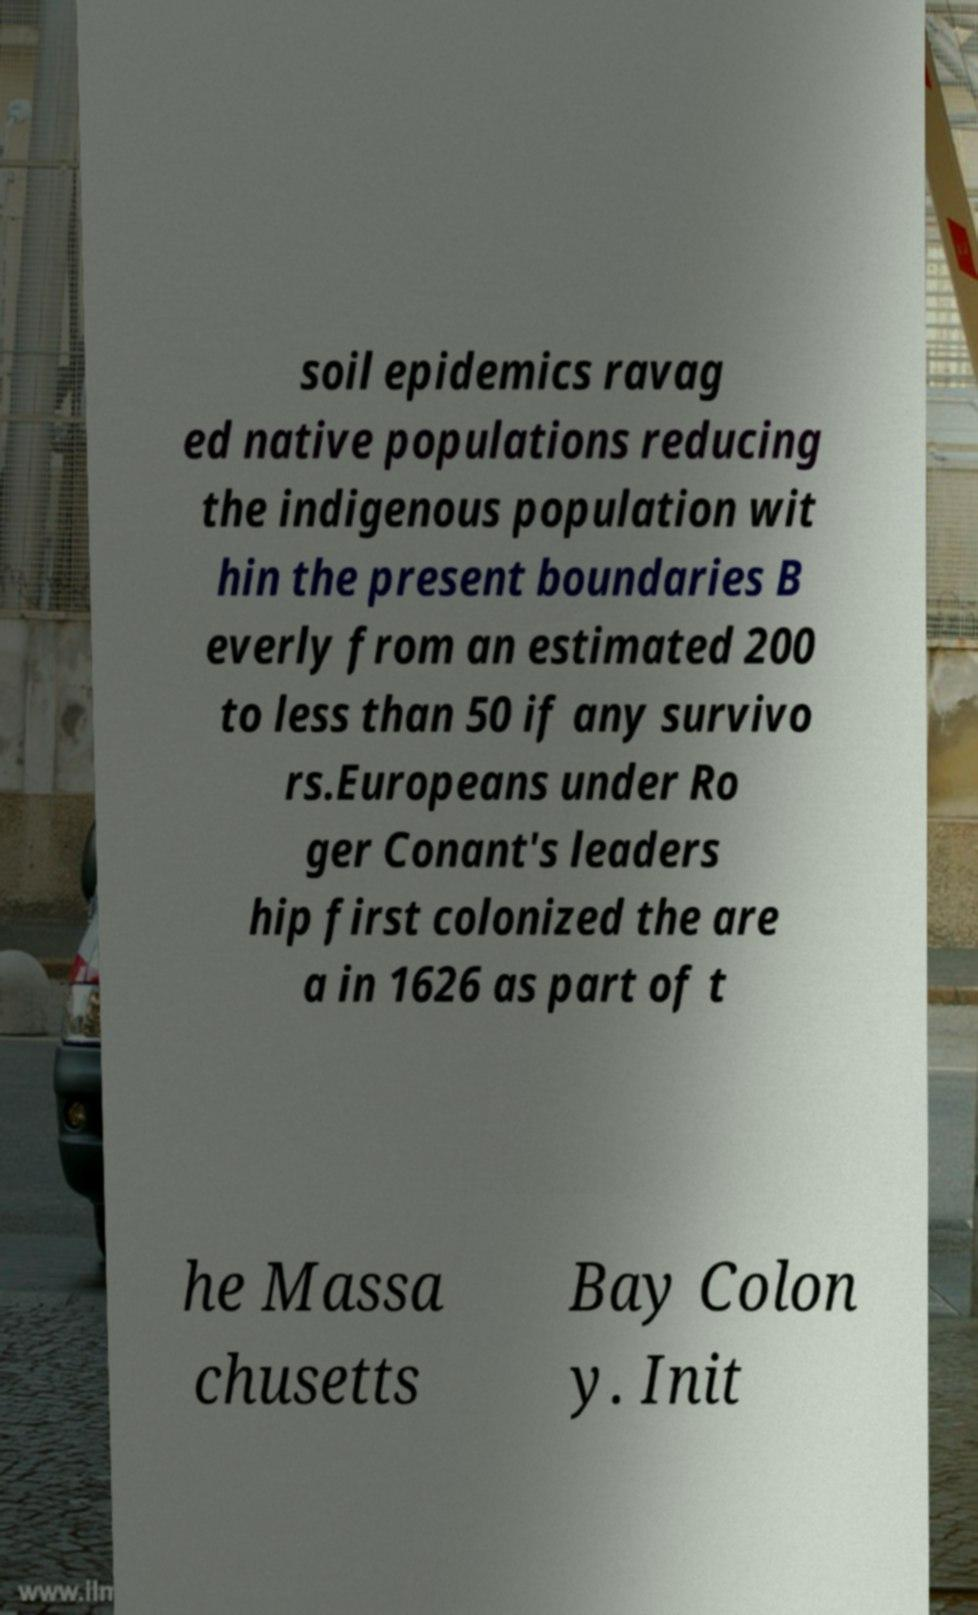There's text embedded in this image that I need extracted. Can you transcribe it verbatim? soil epidemics ravag ed native populations reducing the indigenous population wit hin the present boundaries B everly from an estimated 200 to less than 50 if any survivo rs.Europeans under Ro ger Conant's leaders hip first colonized the are a in 1626 as part of t he Massa chusetts Bay Colon y. Init 